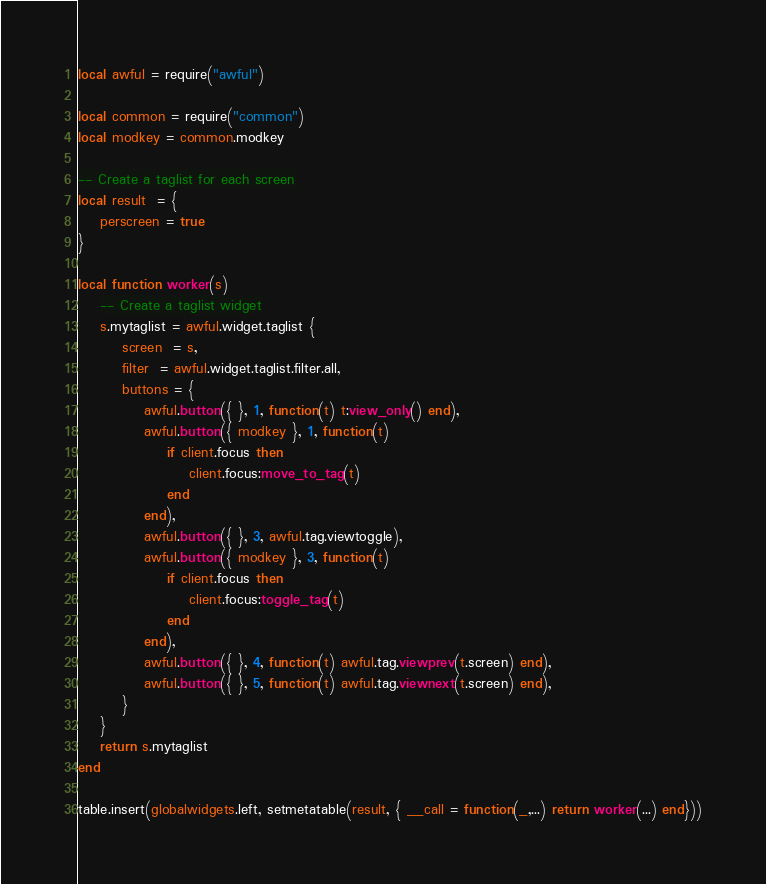<code> <loc_0><loc_0><loc_500><loc_500><_Lua_>local awful = require("awful")

local common = require("common")
local modkey = common.modkey

-- Create a taglist for each screen
local result  = {
    perscreen = true
}

local function worker(s)
    -- Create a taglist widget
    s.mytaglist = awful.widget.taglist {
        screen  = s,
        filter  = awful.widget.taglist.filter.all,
        buttons = {
            awful.button({ }, 1, function(t) t:view_only() end),
            awful.button({ modkey }, 1, function(t)
                if client.focus then
                    client.focus:move_to_tag(t)
                end
            end),
            awful.button({ }, 3, awful.tag.viewtoggle),
            awful.button({ modkey }, 3, function(t)
                if client.focus then
                    client.focus:toggle_tag(t)
                end
            end),
            awful.button({ }, 4, function(t) awful.tag.viewprev(t.screen) end),
            awful.button({ }, 5, function(t) awful.tag.viewnext(t.screen) end),
        }
    }
    return s.mytaglist
end

table.insert(globalwidgets.left, setmetatable(result, { __call = function(_,...) return worker(...) end}))
</code> 